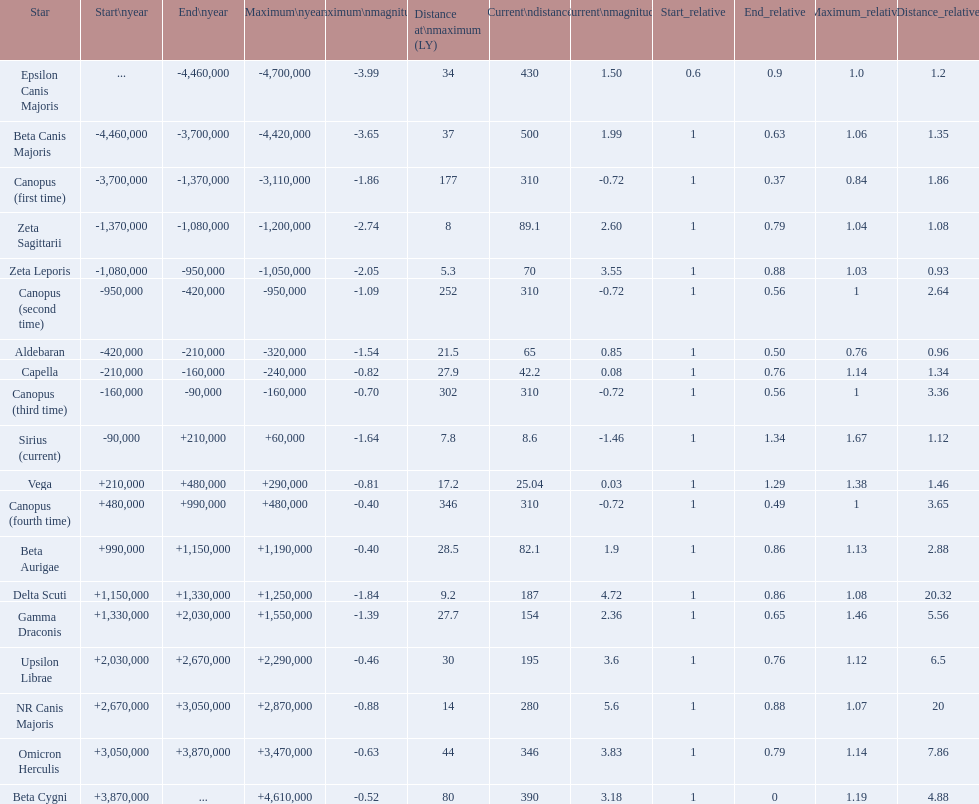What are all the stars? Epsilon Canis Majoris, Beta Canis Majoris, Canopus (first time), Zeta Sagittarii, Zeta Leporis, Canopus (second time), Aldebaran, Capella, Canopus (third time), Sirius (current), Vega, Canopus (fourth time), Beta Aurigae, Delta Scuti, Gamma Draconis, Upsilon Librae, NR Canis Majoris, Omicron Herculis, Beta Cygni. Of those, which star has a maximum distance of 80? Beta Cygni. 